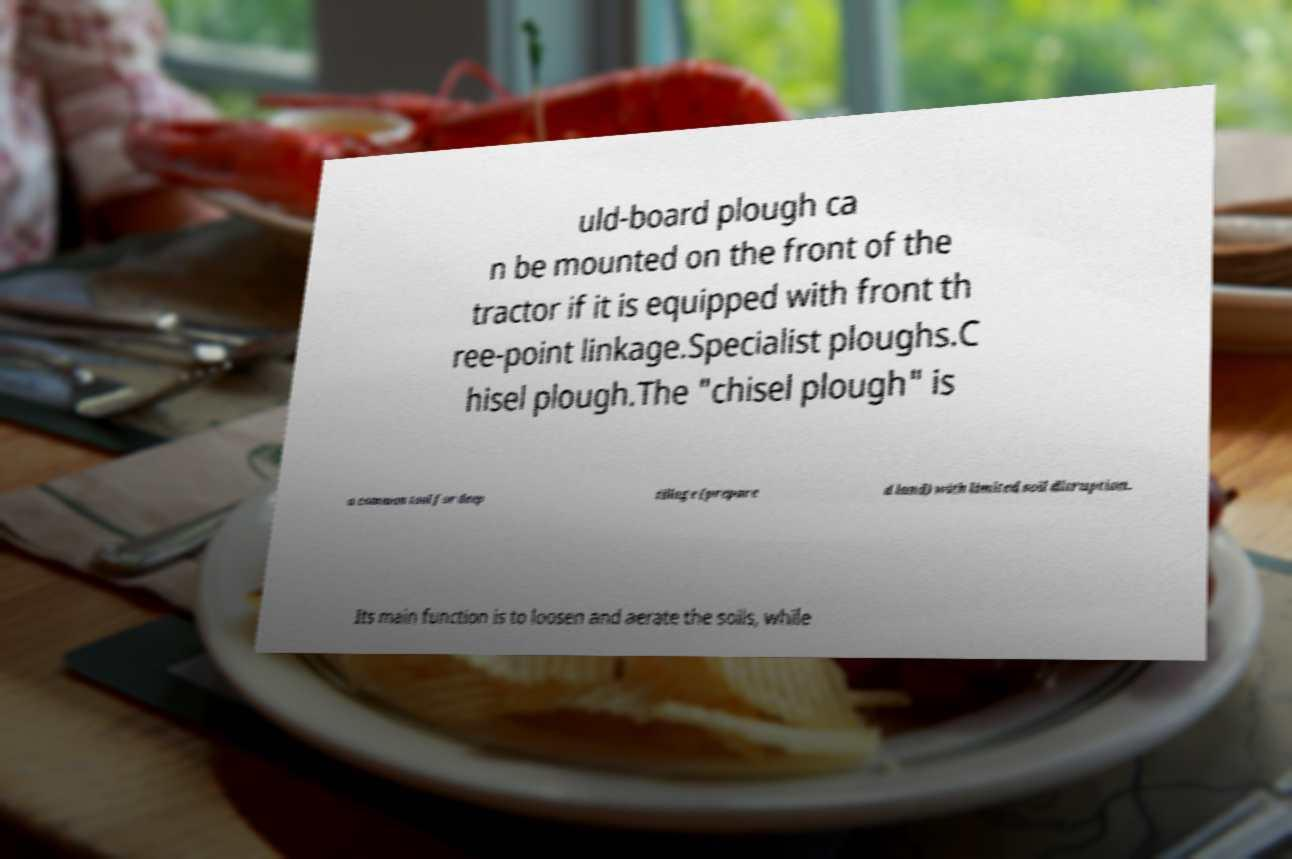Please identify and transcribe the text found in this image. uld-board plough ca n be mounted on the front of the tractor if it is equipped with front th ree-point linkage.Specialist ploughs.C hisel plough.The "chisel plough" is a common tool for deep tillage (prepare d land) with limited soil disruption. Its main function is to loosen and aerate the soils, while 